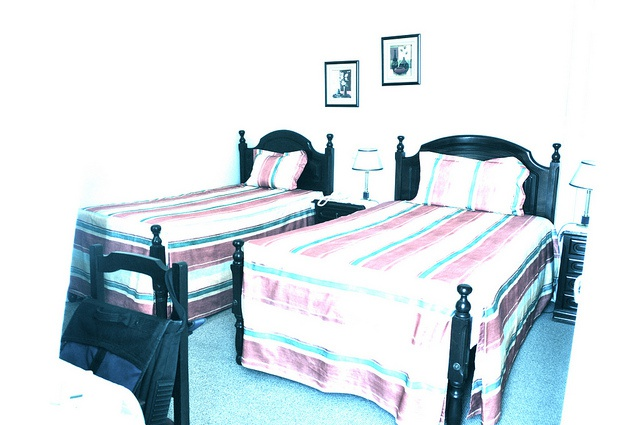Describe the objects in this image and their specific colors. I can see bed in white, navy, lightblue, and blue tones, bed in white, navy, darkgray, and darkblue tones, backpack in white, blue, darkblue, and navy tones, handbag in white, blue, darkblue, and navy tones, and chair in white, blue, darkblue, and navy tones in this image. 